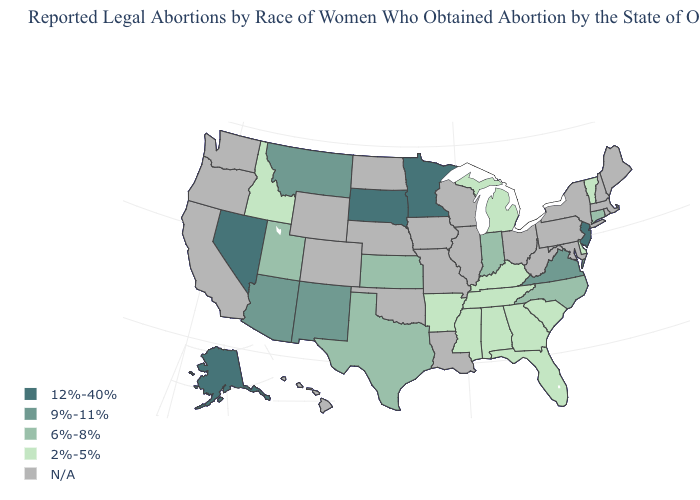Name the states that have a value in the range 6%-8%?
Short answer required. Connecticut, Indiana, Kansas, North Carolina, Texas, Utah. Does the map have missing data?
Short answer required. Yes. What is the lowest value in the USA?
Short answer required. 2%-5%. Name the states that have a value in the range 2%-5%?
Short answer required. Alabama, Arkansas, Delaware, Florida, Georgia, Idaho, Kentucky, Michigan, Mississippi, South Carolina, Tennessee, Vermont. Name the states that have a value in the range 9%-11%?
Keep it brief. Arizona, Montana, New Mexico, Virginia. Does Georgia have the highest value in the South?
Keep it brief. No. Among the states that border Michigan , which have the highest value?
Be succinct. Indiana. Name the states that have a value in the range 9%-11%?
Short answer required. Arizona, Montana, New Mexico, Virginia. What is the lowest value in the West?
Answer briefly. 2%-5%. What is the value of Wyoming?
Answer briefly. N/A. What is the value of Kentucky?
Quick response, please. 2%-5%. What is the highest value in the Northeast ?
Give a very brief answer. 12%-40%. What is the value of Ohio?
Quick response, please. N/A. Does New Jersey have the highest value in the Northeast?
Write a very short answer. Yes. 